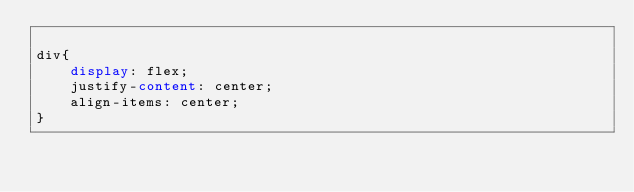<code> <loc_0><loc_0><loc_500><loc_500><_CSS_>
div{
    display: flex;
    justify-content: center;
    align-items: center;
}
</code> 